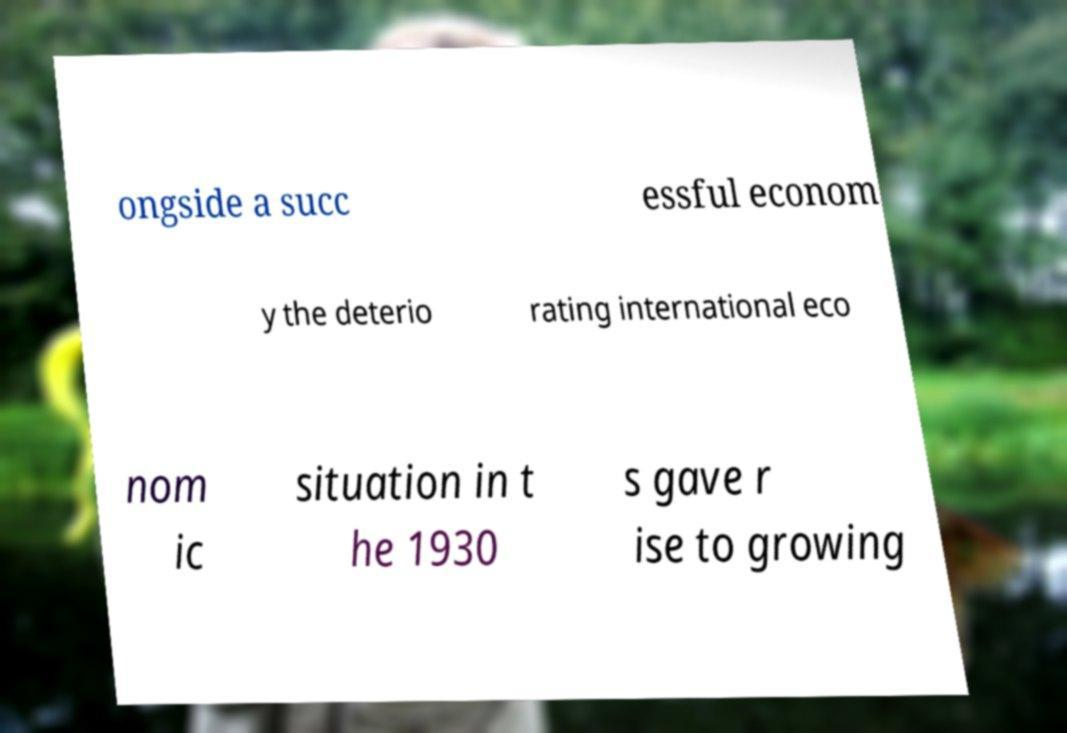I need the written content from this picture converted into text. Can you do that? ongside a succ essful econom y the deterio rating international eco nom ic situation in t he 1930 s gave r ise to growing 